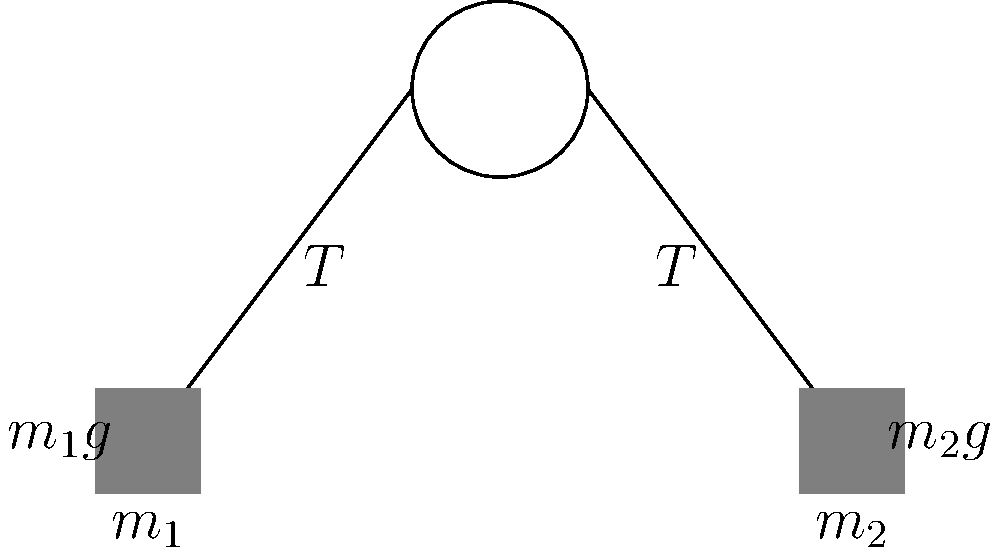In the pulley system shown above, two masses $m_1$ and $m_2$ are connected by an ideal string over a frictionless, massless pulley. Assuming $m_1 > m_2$, analyze the force diagram and explain how the tension in the string relates to the acceleration of the system. How does this analysis contribute to our understanding of argumentation in physics problem-solving? To analyze this pulley system and relate it to argumentation in physics problem-solving, let's break it down step-by-step:

1. Identify forces: For each mass, we have the weight (${m_1g}$ and ${m_2g}$) acting downward and the tension ${T}$ in the string.

2. Apply Newton's Second Law: For $m_1$ (moving down) and $m_2$ (moving up):
   $m_1$: $m_1g - T = m_1a$
   $m_2$: $T - m_2g = m_2a$

3. Recognize that the acceleration is the same magnitude for both masses due to the inextensible string.

4. Add the equations:
   $m_1g - T + T - m_2g = m_1a + m_2a$
   $m_1g - m_2g = (m_1 + m_2)a$

5. Solve for acceleration:
   $a = \frac{m_1g - m_2g}{m_1 + m_2} = g\frac{m_1 - m_2}{m_1 + m_2}$

6. Substitute this back into either equation to find tension:
   $T = m_2(g + a) = m_2g + m_2g\frac{m_1 - m_2}{m_1 + m_2} = \frac{2m_1m_2g}{m_1 + m_2}$

From a discourse analysis perspective, this problem-solving process demonstrates several key aspects of argumentation in physics:

1. Systematic decomposition: Breaking down the problem into manageable steps.
2. Principle application: Using fundamental laws (Newton's Second Law) to frame the argument.
3. Logical inference: Drawing conclusions from the application of principles to the specific scenario.
4. Mathematical reasoning: Using algebra to manipulate equations and derive new insights.
5. System thinking: Considering how the components (masses, string, pulley) interact as a whole.
6. Consistency checking: Ensuring that the derived equations are dimensionally consistent and physically reasonable.

This analysis reveals how physicists construct arguments by combining conceptual understanding with mathematical formalism. It also highlights the importance of clearly stating assumptions (e.g., ideal string, frictionless pulley) in building a coherent argument.
Answer: $T = \frac{2m_1m_2g}{m_1 + m_2}$ 